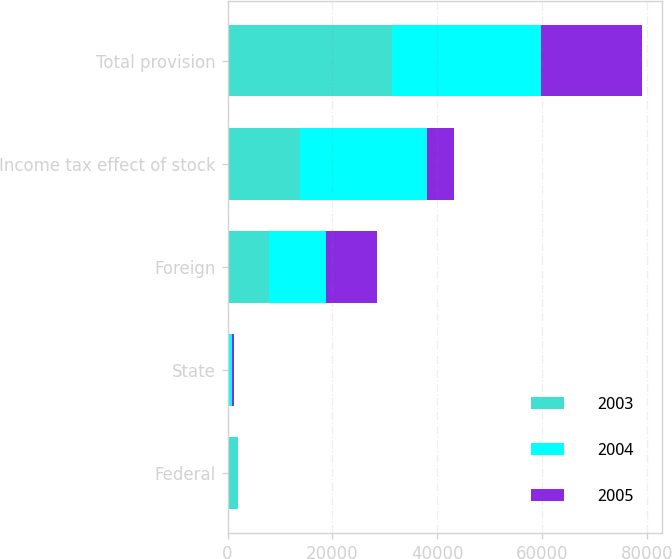<chart> <loc_0><loc_0><loc_500><loc_500><stacked_bar_chart><ecel><fcel>Federal<fcel>State<fcel>Foreign<fcel>Income tax effect of stock<fcel>Total provision<nl><fcel>2003<fcel>1914<fcel>214<fcel>7985<fcel>13916<fcel>31459<nl><fcel>2004<fcel>20<fcel>590<fcel>10738<fcel>24223<fcel>28414<nl><fcel>2005<fcel>88<fcel>468<fcel>9708<fcel>5117<fcel>19155<nl></chart> 